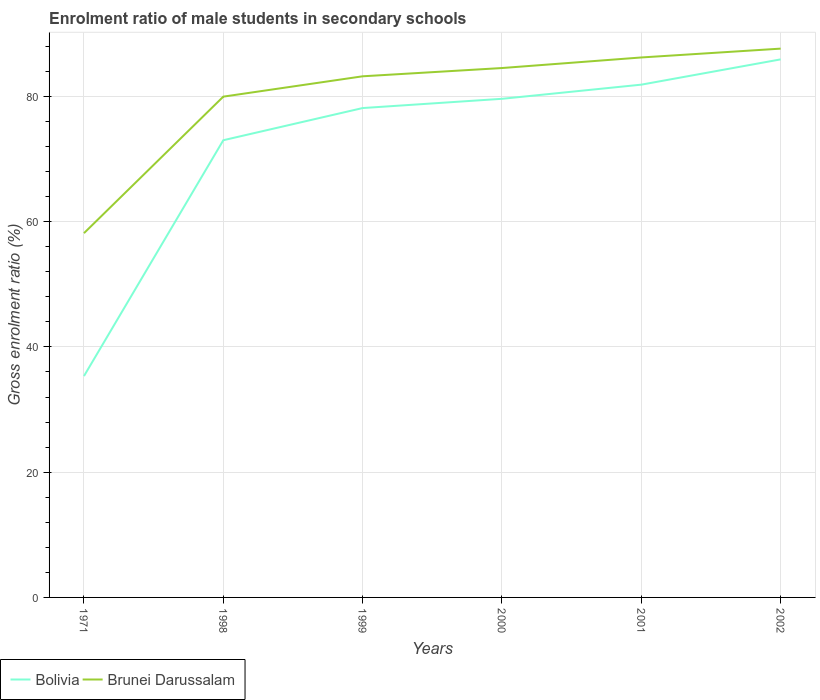Is the number of lines equal to the number of legend labels?
Your response must be concise. Yes. Across all years, what is the maximum enrolment ratio of male students in secondary schools in Bolivia?
Offer a terse response. 35.34. What is the total enrolment ratio of male students in secondary schools in Bolivia in the graph?
Your response must be concise. -44.27. What is the difference between the highest and the second highest enrolment ratio of male students in secondary schools in Bolivia?
Offer a terse response. 50.57. Is the enrolment ratio of male students in secondary schools in Bolivia strictly greater than the enrolment ratio of male students in secondary schools in Brunei Darussalam over the years?
Make the answer very short. Yes. What is the difference between two consecutive major ticks on the Y-axis?
Ensure brevity in your answer.  20. Are the values on the major ticks of Y-axis written in scientific E-notation?
Your answer should be compact. No. Does the graph contain any zero values?
Offer a terse response. No. Does the graph contain grids?
Make the answer very short. Yes. How are the legend labels stacked?
Give a very brief answer. Horizontal. What is the title of the graph?
Ensure brevity in your answer.  Enrolment ratio of male students in secondary schools. What is the label or title of the X-axis?
Provide a succinct answer. Years. What is the label or title of the Y-axis?
Keep it short and to the point. Gross enrolment ratio (%). What is the Gross enrolment ratio (%) in Bolivia in 1971?
Ensure brevity in your answer.  35.34. What is the Gross enrolment ratio (%) of Brunei Darussalam in 1971?
Ensure brevity in your answer.  58.16. What is the Gross enrolment ratio (%) of Bolivia in 1998?
Provide a short and direct response. 73. What is the Gross enrolment ratio (%) in Brunei Darussalam in 1998?
Your response must be concise. 79.96. What is the Gross enrolment ratio (%) in Bolivia in 1999?
Keep it short and to the point. 78.14. What is the Gross enrolment ratio (%) of Brunei Darussalam in 1999?
Your answer should be very brief. 83.21. What is the Gross enrolment ratio (%) of Bolivia in 2000?
Your response must be concise. 79.62. What is the Gross enrolment ratio (%) in Brunei Darussalam in 2000?
Offer a very short reply. 84.53. What is the Gross enrolment ratio (%) in Bolivia in 2001?
Ensure brevity in your answer.  81.88. What is the Gross enrolment ratio (%) of Brunei Darussalam in 2001?
Provide a short and direct response. 86.22. What is the Gross enrolment ratio (%) in Bolivia in 2002?
Provide a short and direct response. 85.91. What is the Gross enrolment ratio (%) in Brunei Darussalam in 2002?
Make the answer very short. 87.63. Across all years, what is the maximum Gross enrolment ratio (%) of Bolivia?
Your response must be concise. 85.91. Across all years, what is the maximum Gross enrolment ratio (%) of Brunei Darussalam?
Give a very brief answer. 87.63. Across all years, what is the minimum Gross enrolment ratio (%) in Bolivia?
Keep it short and to the point. 35.34. Across all years, what is the minimum Gross enrolment ratio (%) in Brunei Darussalam?
Offer a terse response. 58.16. What is the total Gross enrolment ratio (%) in Bolivia in the graph?
Your answer should be compact. 433.89. What is the total Gross enrolment ratio (%) in Brunei Darussalam in the graph?
Your answer should be very brief. 479.71. What is the difference between the Gross enrolment ratio (%) in Bolivia in 1971 and that in 1998?
Your answer should be compact. -37.66. What is the difference between the Gross enrolment ratio (%) of Brunei Darussalam in 1971 and that in 1998?
Offer a very short reply. -21.8. What is the difference between the Gross enrolment ratio (%) in Bolivia in 1971 and that in 1999?
Give a very brief answer. -42.79. What is the difference between the Gross enrolment ratio (%) in Brunei Darussalam in 1971 and that in 1999?
Your answer should be very brief. -25.05. What is the difference between the Gross enrolment ratio (%) in Bolivia in 1971 and that in 2000?
Your answer should be compact. -44.27. What is the difference between the Gross enrolment ratio (%) in Brunei Darussalam in 1971 and that in 2000?
Offer a terse response. -26.37. What is the difference between the Gross enrolment ratio (%) of Bolivia in 1971 and that in 2001?
Make the answer very short. -46.53. What is the difference between the Gross enrolment ratio (%) of Brunei Darussalam in 1971 and that in 2001?
Provide a succinct answer. -28.05. What is the difference between the Gross enrolment ratio (%) in Bolivia in 1971 and that in 2002?
Ensure brevity in your answer.  -50.57. What is the difference between the Gross enrolment ratio (%) in Brunei Darussalam in 1971 and that in 2002?
Provide a short and direct response. -29.47. What is the difference between the Gross enrolment ratio (%) of Bolivia in 1998 and that in 1999?
Ensure brevity in your answer.  -5.14. What is the difference between the Gross enrolment ratio (%) in Brunei Darussalam in 1998 and that in 1999?
Your response must be concise. -3.25. What is the difference between the Gross enrolment ratio (%) of Bolivia in 1998 and that in 2000?
Make the answer very short. -6.61. What is the difference between the Gross enrolment ratio (%) of Brunei Darussalam in 1998 and that in 2000?
Make the answer very short. -4.57. What is the difference between the Gross enrolment ratio (%) of Bolivia in 1998 and that in 2001?
Your response must be concise. -8.87. What is the difference between the Gross enrolment ratio (%) of Brunei Darussalam in 1998 and that in 2001?
Provide a succinct answer. -6.26. What is the difference between the Gross enrolment ratio (%) of Bolivia in 1998 and that in 2002?
Give a very brief answer. -12.91. What is the difference between the Gross enrolment ratio (%) of Brunei Darussalam in 1998 and that in 2002?
Make the answer very short. -7.67. What is the difference between the Gross enrolment ratio (%) of Bolivia in 1999 and that in 2000?
Provide a short and direct response. -1.48. What is the difference between the Gross enrolment ratio (%) of Brunei Darussalam in 1999 and that in 2000?
Offer a terse response. -1.32. What is the difference between the Gross enrolment ratio (%) in Bolivia in 1999 and that in 2001?
Provide a short and direct response. -3.74. What is the difference between the Gross enrolment ratio (%) of Brunei Darussalam in 1999 and that in 2001?
Your response must be concise. -3.01. What is the difference between the Gross enrolment ratio (%) of Bolivia in 1999 and that in 2002?
Provide a short and direct response. -7.77. What is the difference between the Gross enrolment ratio (%) in Brunei Darussalam in 1999 and that in 2002?
Make the answer very short. -4.42. What is the difference between the Gross enrolment ratio (%) in Bolivia in 2000 and that in 2001?
Offer a terse response. -2.26. What is the difference between the Gross enrolment ratio (%) of Brunei Darussalam in 2000 and that in 2001?
Offer a very short reply. -1.69. What is the difference between the Gross enrolment ratio (%) in Bolivia in 2000 and that in 2002?
Your answer should be compact. -6.3. What is the difference between the Gross enrolment ratio (%) in Brunei Darussalam in 2000 and that in 2002?
Provide a short and direct response. -3.1. What is the difference between the Gross enrolment ratio (%) of Bolivia in 2001 and that in 2002?
Your answer should be compact. -4.04. What is the difference between the Gross enrolment ratio (%) in Brunei Darussalam in 2001 and that in 2002?
Provide a short and direct response. -1.41. What is the difference between the Gross enrolment ratio (%) of Bolivia in 1971 and the Gross enrolment ratio (%) of Brunei Darussalam in 1998?
Keep it short and to the point. -44.62. What is the difference between the Gross enrolment ratio (%) of Bolivia in 1971 and the Gross enrolment ratio (%) of Brunei Darussalam in 1999?
Keep it short and to the point. -47.86. What is the difference between the Gross enrolment ratio (%) in Bolivia in 1971 and the Gross enrolment ratio (%) in Brunei Darussalam in 2000?
Your answer should be compact. -49.18. What is the difference between the Gross enrolment ratio (%) in Bolivia in 1971 and the Gross enrolment ratio (%) in Brunei Darussalam in 2001?
Your answer should be very brief. -50.87. What is the difference between the Gross enrolment ratio (%) in Bolivia in 1971 and the Gross enrolment ratio (%) in Brunei Darussalam in 2002?
Your response must be concise. -52.28. What is the difference between the Gross enrolment ratio (%) of Bolivia in 1998 and the Gross enrolment ratio (%) of Brunei Darussalam in 1999?
Offer a very short reply. -10.21. What is the difference between the Gross enrolment ratio (%) in Bolivia in 1998 and the Gross enrolment ratio (%) in Brunei Darussalam in 2000?
Keep it short and to the point. -11.53. What is the difference between the Gross enrolment ratio (%) of Bolivia in 1998 and the Gross enrolment ratio (%) of Brunei Darussalam in 2001?
Your answer should be very brief. -13.22. What is the difference between the Gross enrolment ratio (%) of Bolivia in 1998 and the Gross enrolment ratio (%) of Brunei Darussalam in 2002?
Offer a very short reply. -14.63. What is the difference between the Gross enrolment ratio (%) in Bolivia in 1999 and the Gross enrolment ratio (%) in Brunei Darussalam in 2000?
Ensure brevity in your answer.  -6.39. What is the difference between the Gross enrolment ratio (%) of Bolivia in 1999 and the Gross enrolment ratio (%) of Brunei Darussalam in 2001?
Provide a short and direct response. -8.08. What is the difference between the Gross enrolment ratio (%) of Bolivia in 1999 and the Gross enrolment ratio (%) of Brunei Darussalam in 2002?
Offer a terse response. -9.49. What is the difference between the Gross enrolment ratio (%) in Bolivia in 2000 and the Gross enrolment ratio (%) in Brunei Darussalam in 2001?
Your answer should be compact. -6.6. What is the difference between the Gross enrolment ratio (%) in Bolivia in 2000 and the Gross enrolment ratio (%) in Brunei Darussalam in 2002?
Provide a succinct answer. -8.01. What is the difference between the Gross enrolment ratio (%) in Bolivia in 2001 and the Gross enrolment ratio (%) in Brunei Darussalam in 2002?
Make the answer very short. -5.75. What is the average Gross enrolment ratio (%) of Bolivia per year?
Provide a succinct answer. 72.31. What is the average Gross enrolment ratio (%) of Brunei Darussalam per year?
Ensure brevity in your answer.  79.95. In the year 1971, what is the difference between the Gross enrolment ratio (%) in Bolivia and Gross enrolment ratio (%) in Brunei Darussalam?
Provide a succinct answer. -22.82. In the year 1998, what is the difference between the Gross enrolment ratio (%) of Bolivia and Gross enrolment ratio (%) of Brunei Darussalam?
Offer a terse response. -6.96. In the year 1999, what is the difference between the Gross enrolment ratio (%) in Bolivia and Gross enrolment ratio (%) in Brunei Darussalam?
Offer a terse response. -5.07. In the year 2000, what is the difference between the Gross enrolment ratio (%) of Bolivia and Gross enrolment ratio (%) of Brunei Darussalam?
Your response must be concise. -4.91. In the year 2001, what is the difference between the Gross enrolment ratio (%) of Bolivia and Gross enrolment ratio (%) of Brunei Darussalam?
Keep it short and to the point. -4.34. In the year 2002, what is the difference between the Gross enrolment ratio (%) in Bolivia and Gross enrolment ratio (%) in Brunei Darussalam?
Ensure brevity in your answer.  -1.72. What is the ratio of the Gross enrolment ratio (%) in Bolivia in 1971 to that in 1998?
Your answer should be compact. 0.48. What is the ratio of the Gross enrolment ratio (%) of Brunei Darussalam in 1971 to that in 1998?
Your answer should be compact. 0.73. What is the ratio of the Gross enrolment ratio (%) in Bolivia in 1971 to that in 1999?
Offer a terse response. 0.45. What is the ratio of the Gross enrolment ratio (%) in Brunei Darussalam in 1971 to that in 1999?
Your answer should be compact. 0.7. What is the ratio of the Gross enrolment ratio (%) in Bolivia in 1971 to that in 2000?
Your response must be concise. 0.44. What is the ratio of the Gross enrolment ratio (%) in Brunei Darussalam in 1971 to that in 2000?
Offer a terse response. 0.69. What is the ratio of the Gross enrolment ratio (%) of Bolivia in 1971 to that in 2001?
Offer a very short reply. 0.43. What is the ratio of the Gross enrolment ratio (%) in Brunei Darussalam in 1971 to that in 2001?
Keep it short and to the point. 0.67. What is the ratio of the Gross enrolment ratio (%) in Bolivia in 1971 to that in 2002?
Your answer should be very brief. 0.41. What is the ratio of the Gross enrolment ratio (%) in Brunei Darussalam in 1971 to that in 2002?
Offer a terse response. 0.66. What is the ratio of the Gross enrolment ratio (%) of Bolivia in 1998 to that in 1999?
Provide a short and direct response. 0.93. What is the ratio of the Gross enrolment ratio (%) in Brunei Darussalam in 1998 to that in 1999?
Keep it short and to the point. 0.96. What is the ratio of the Gross enrolment ratio (%) of Bolivia in 1998 to that in 2000?
Offer a terse response. 0.92. What is the ratio of the Gross enrolment ratio (%) of Brunei Darussalam in 1998 to that in 2000?
Your answer should be compact. 0.95. What is the ratio of the Gross enrolment ratio (%) of Bolivia in 1998 to that in 2001?
Provide a succinct answer. 0.89. What is the ratio of the Gross enrolment ratio (%) of Brunei Darussalam in 1998 to that in 2001?
Your answer should be compact. 0.93. What is the ratio of the Gross enrolment ratio (%) in Bolivia in 1998 to that in 2002?
Offer a very short reply. 0.85. What is the ratio of the Gross enrolment ratio (%) in Brunei Darussalam in 1998 to that in 2002?
Provide a short and direct response. 0.91. What is the ratio of the Gross enrolment ratio (%) of Bolivia in 1999 to that in 2000?
Your answer should be very brief. 0.98. What is the ratio of the Gross enrolment ratio (%) of Brunei Darussalam in 1999 to that in 2000?
Your answer should be compact. 0.98. What is the ratio of the Gross enrolment ratio (%) of Bolivia in 1999 to that in 2001?
Offer a very short reply. 0.95. What is the ratio of the Gross enrolment ratio (%) in Brunei Darussalam in 1999 to that in 2001?
Provide a succinct answer. 0.97. What is the ratio of the Gross enrolment ratio (%) of Bolivia in 1999 to that in 2002?
Provide a succinct answer. 0.91. What is the ratio of the Gross enrolment ratio (%) in Brunei Darussalam in 1999 to that in 2002?
Your answer should be very brief. 0.95. What is the ratio of the Gross enrolment ratio (%) of Bolivia in 2000 to that in 2001?
Make the answer very short. 0.97. What is the ratio of the Gross enrolment ratio (%) in Brunei Darussalam in 2000 to that in 2001?
Make the answer very short. 0.98. What is the ratio of the Gross enrolment ratio (%) of Bolivia in 2000 to that in 2002?
Make the answer very short. 0.93. What is the ratio of the Gross enrolment ratio (%) in Brunei Darussalam in 2000 to that in 2002?
Provide a succinct answer. 0.96. What is the ratio of the Gross enrolment ratio (%) in Bolivia in 2001 to that in 2002?
Make the answer very short. 0.95. What is the ratio of the Gross enrolment ratio (%) of Brunei Darussalam in 2001 to that in 2002?
Give a very brief answer. 0.98. What is the difference between the highest and the second highest Gross enrolment ratio (%) in Bolivia?
Ensure brevity in your answer.  4.04. What is the difference between the highest and the second highest Gross enrolment ratio (%) of Brunei Darussalam?
Offer a terse response. 1.41. What is the difference between the highest and the lowest Gross enrolment ratio (%) of Bolivia?
Your response must be concise. 50.57. What is the difference between the highest and the lowest Gross enrolment ratio (%) in Brunei Darussalam?
Your response must be concise. 29.47. 